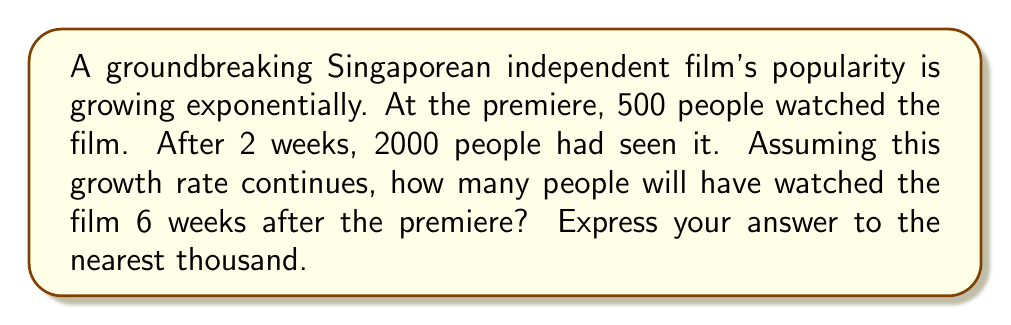Teach me how to tackle this problem. Let's approach this step-by-step:

1) We can model this scenario using the exponential growth formula:
   $$ A = P(1 + r)^t $$
   where A is the final amount, P is the initial amount, r is the growth rate, and t is the time period.

2) We know:
   P = 500 (initial viewers)
   After 2 weeks, A = 2000
   We need to find r (growth rate per week)

3) Plugging in the known values:
   $$ 2000 = 500(1 + r)^2 $$

4) Simplify:
   $$ 4 = (1 + r)^2 $$

5) Take the square root of both sides:
   $$ \sqrt{4} = 1 + r $$
   $$ 2 = 1 + r $$
   $$ r = 1 $$

6) So, the growth rate is 100% per week.

7) Now, to find the number of viewers after 6 weeks:
   $$ A = 500(1 + 1)^6 $$
   $$ A = 500(2)^6 $$
   $$ A = 500(64) $$
   $$ A = 32,000 $$

8) Rounding to the nearest thousand:
   32,000 ≈ 32,000
Answer: 32,000 